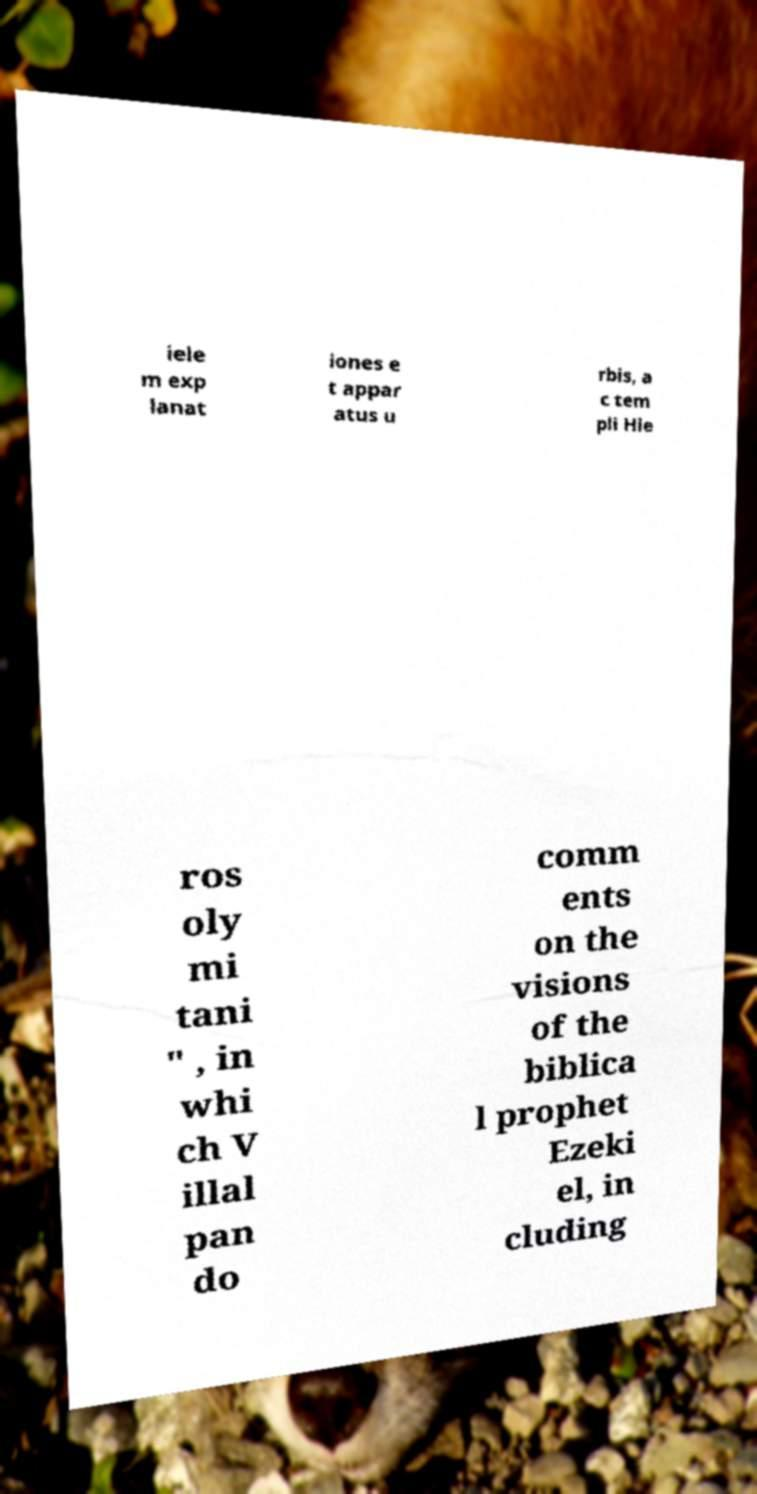Please identify and transcribe the text found in this image. iele m exp lanat iones e t appar atus u rbis, a c tem pli Hie ros oly mi tani " , in whi ch V illal pan do comm ents on the visions of the biblica l prophet Ezeki el, in cluding 